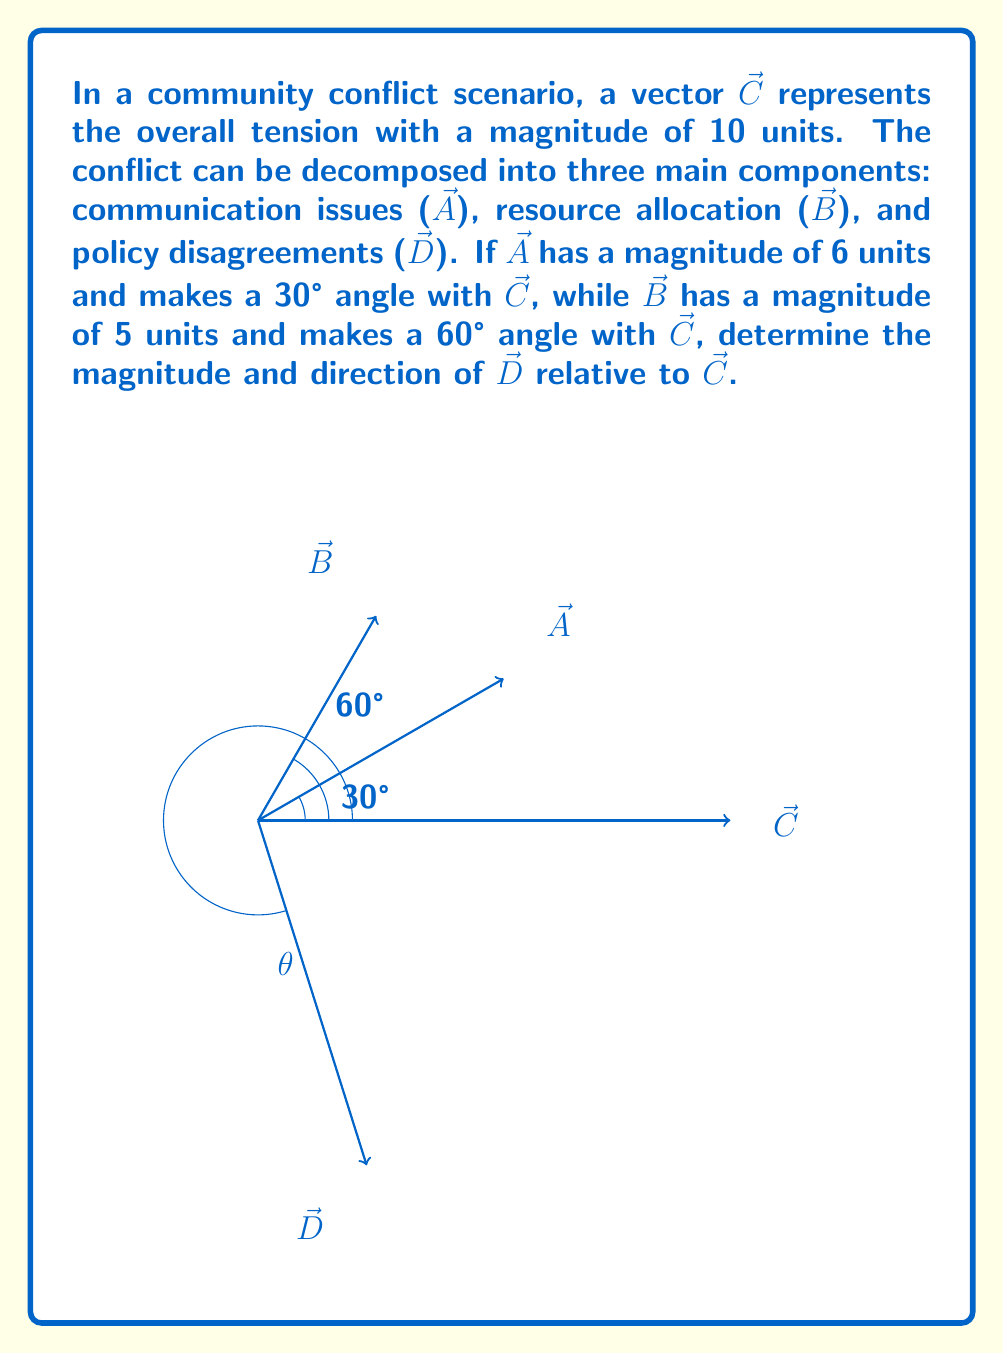Teach me how to tackle this problem. Let's approach this step-by-step:

1) First, we need to find the x and y components of vectors $\vec{A}$ and $\vec{B}$:

   $\vec{A}_x = 6 \cos(30°) = 6 \cdot \frac{\sqrt{3}}{2} = 3\sqrt{3}$
   $\vec{A}_y = 6 \sin(30°) = 6 \cdot \frac{1}{2} = 3$

   $\vec{B}_x = 5 \cos(60°) = 5 \cdot \frac{1}{2} = 2.5$
   $\vec{B}_y = 5 \sin(60°) = 5 \cdot \frac{\sqrt{3}}{2} = 2.5\sqrt{3}$

2) Now, we can use vector addition to find the components of $\vec{D}$:

   $\vec{D}_x + \vec{A}_x + \vec{B}_x = \vec{C}_x = 10$
   $\vec{D}_x = 10 - (3\sqrt{3} + 2.5) = 10 - 5.2 - 2.5 = 2.3$

   $\vec{D}_y + \vec{A}_y + \vec{B}_y = \vec{C}_y = 0$
   $\vec{D}_y = -(3 + 2.5\sqrt{3}) = -7.3$

3) We can find the magnitude of $\vec{D}$ using the Pythagorean theorem:

   $|\vec{D}| = \sqrt{(2.3)^2 + (-7.3)^2} \approx 7.7$

4) To find the angle $\theta$ that $\vec{D}$ makes with $\vec{C}$, we can use the arctangent function:

   $\theta = \arctan(\frac{-7.3}{2.3}) \approx -72.5°$

   However, since the angle is measured clockwise from $\vec{C}$, we need to add 360° to get the positive angle:

   $\theta = 360° - 72.5° = 287.5°$
Answer: $|\vec{D}| \approx 7.7$, $\theta \approx 287.5°$ 